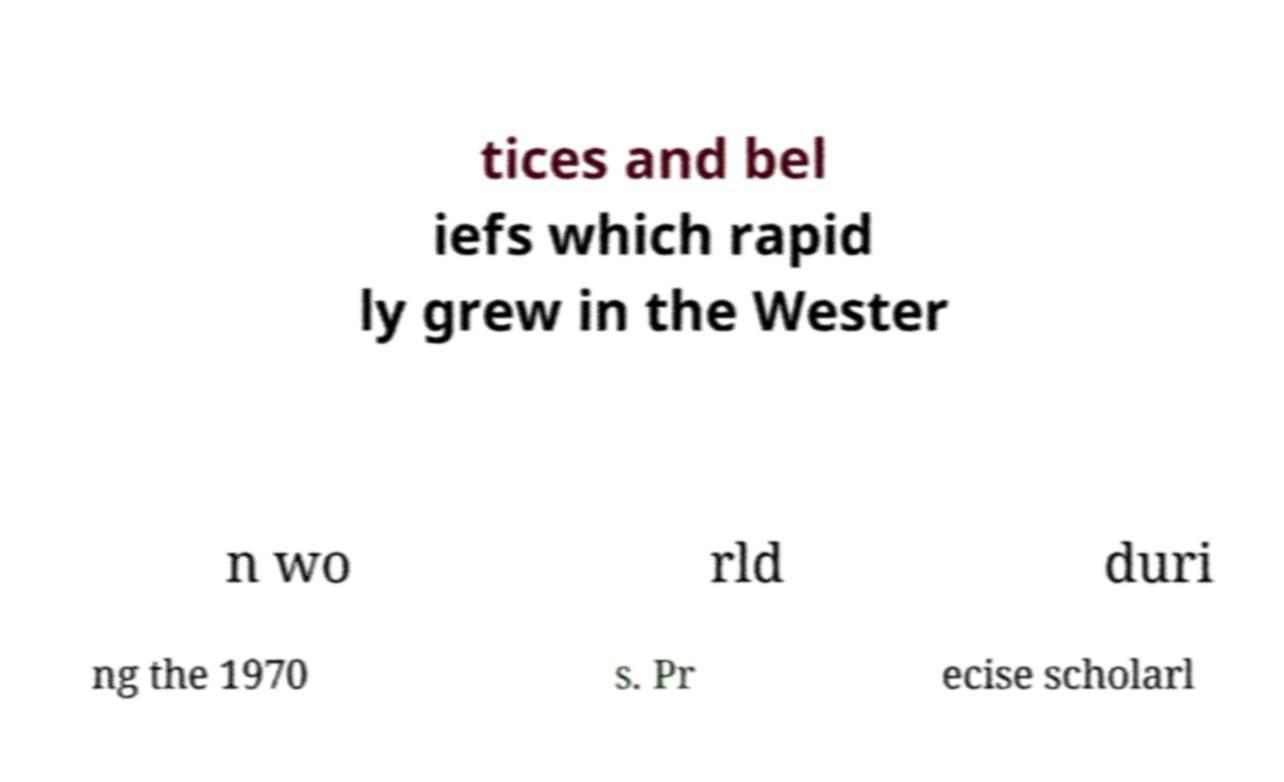Please read and relay the text visible in this image. What does it say? tices and bel iefs which rapid ly grew in the Wester n wo rld duri ng the 1970 s. Pr ecise scholarl 